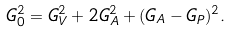Convert formula to latex. <formula><loc_0><loc_0><loc_500><loc_500>G _ { 0 } ^ { 2 } = G _ { V } ^ { 2 } + 2 G _ { A } ^ { 2 } + ( G _ { A } - G _ { P } ) ^ { 2 } .</formula> 